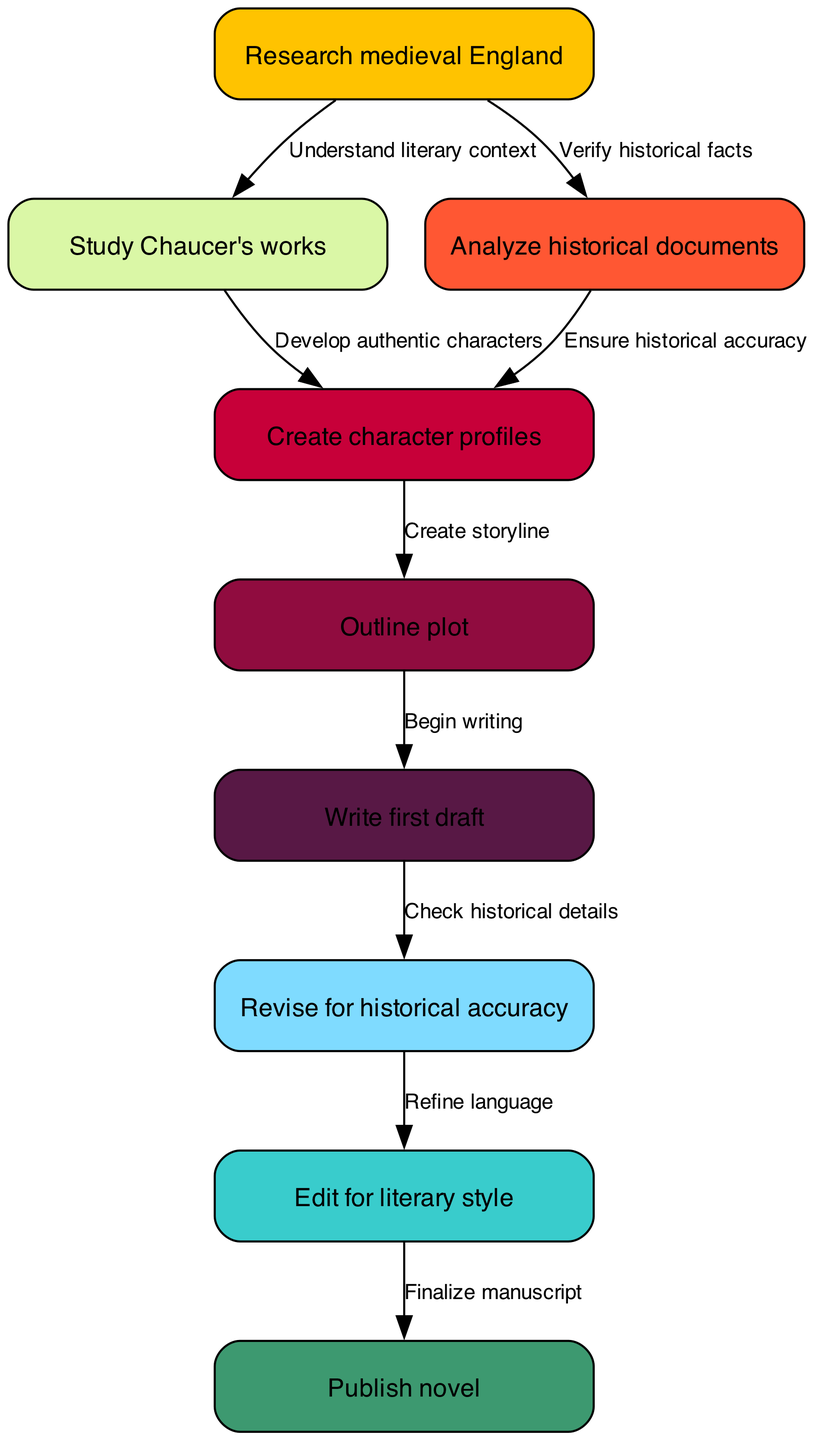What is the first step in the writing process? The first node in the diagram is "Research medieval England," indicating it is the starting point of the writing process.
Answer: Research medieval England How many nodes are present in the diagram? The diagram lists a total of nine nodes, each representing a specific part of the writing process.
Answer: 9 What follows "Create character profiles"? The diagram shows that "Create character profiles" is connected to "Outline plot," indicating that outlining the plot follows character profile creation.
Answer: Outline plot Which node is directly connected to "Revise for historical accuracy"? The node directly connected after "Revise for historical accuracy" is "Edit for literary style," meaning it comes next in the process.
Answer: Edit for literary style What type of documents should be analyzed to ensure character authenticity? The edge between "Study Chaucer's works" and "Create character profiles" suggests that studying literary works contributes to developing authentic characters.
Answer: Literary works What is the relationship between "Research medieval England" and "Analyze historical documents"? The diagram indicates that "Research medieval England" leads to both understanding literary context and verifying historical facts, which are foundational for analysis.
Answer: Verify historical facts After writing the first draft, what is the next task? The flow from "Write first draft" leads directly to "Revise for historical accuracy," meaning revision for historical accuracy is the next task after the first draft.
Answer: Revise for historical accuracy From which node does the path to publication begin? The path to publication in the diagram starts from "Edit for literary style," leading to "Publish novel" as the final step.
Answer: Edit for literary style What is the connection between character profiles and plotting? The diagram shows that "Create character profiles" is directly connected to "Outline plot," indicating that character profiles influence plot development.
Answer: Create storyline 